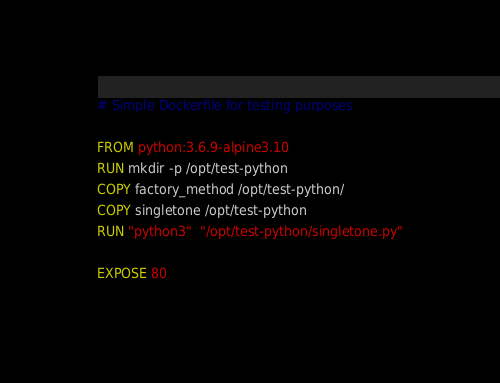<code> <loc_0><loc_0><loc_500><loc_500><_Dockerfile_># Simple Dockerfile for testing purposes

FROM python:3.6.9-alpine3.10
RUN mkdir -p /opt/test-python
COPY factory_method /opt/test-python/
COPY singletone /opt/test-python
RUN "python3"  "/opt/test-python/singletone.py"

EXPOSE 80
</code> 